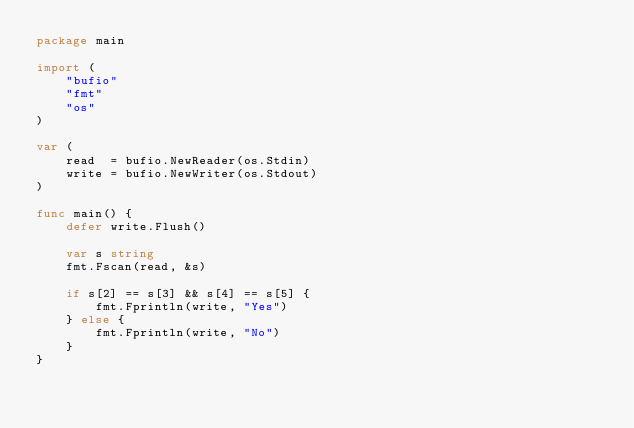<code> <loc_0><loc_0><loc_500><loc_500><_Go_>package main

import (
	"bufio"
	"fmt"
	"os"
)

var (
	read  = bufio.NewReader(os.Stdin)
	write = bufio.NewWriter(os.Stdout)
)

func main() {
	defer write.Flush()

	var s string
	fmt.Fscan(read, &s)

	if s[2] == s[3] && s[4] == s[5] {
		fmt.Fprintln(write, "Yes")
	} else {
		fmt.Fprintln(write, "No")
	}
}
</code> 